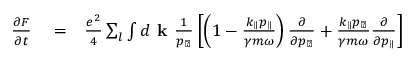Convert formula to latex. <formula><loc_0><loc_0><loc_500><loc_500>\begin{array} { r l r } { \frac { \partial F } { \partial t } } & = } & { \frac { e ^ { 2 } } { 4 } \sum _ { l } \int d k \frac { 1 } { p _ { \perp } } \left [ \left ( 1 - \frac { k _ { \| } p _ { \| } } { \gamma m \omega } \right ) \frac { \partial } { \partial p _ { \perp } } + \frac { k _ { \| } p _ { \perp } } { \gamma m \omega } \frac { \partial } { \partial p _ { \| } } \right ] } \end{array}</formula> 